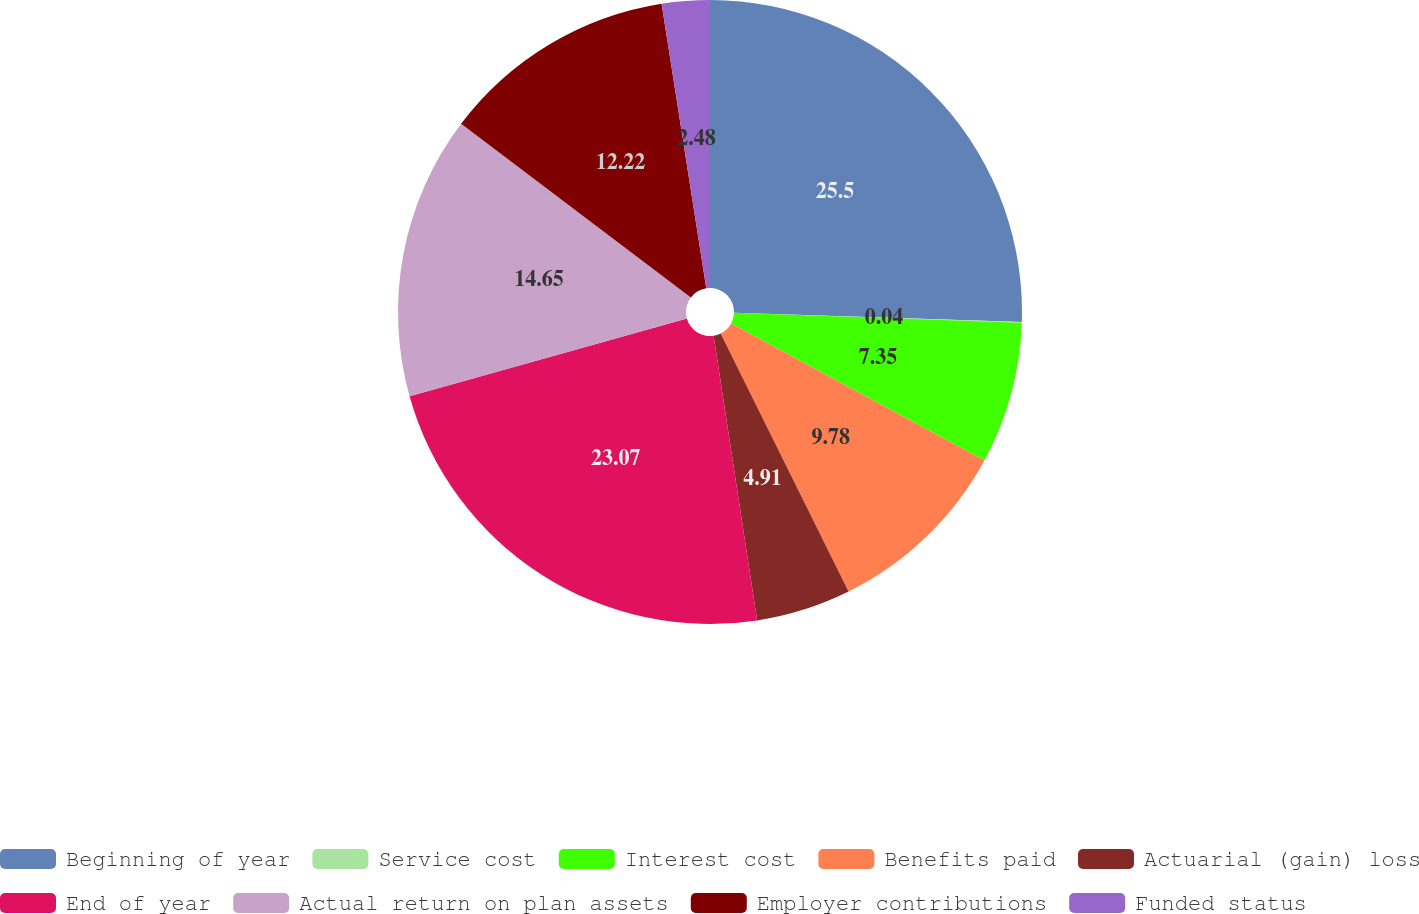<chart> <loc_0><loc_0><loc_500><loc_500><pie_chart><fcel>Beginning of year<fcel>Service cost<fcel>Interest cost<fcel>Benefits paid<fcel>Actuarial (gain) loss<fcel>End of year<fcel>Actual return on plan assets<fcel>Employer contributions<fcel>Funded status<nl><fcel>25.51%<fcel>0.04%<fcel>7.35%<fcel>9.78%<fcel>4.91%<fcel>23.07%<fcel>14.65%<fcel>12.22%<fcel>2.48%<nl></chart> 